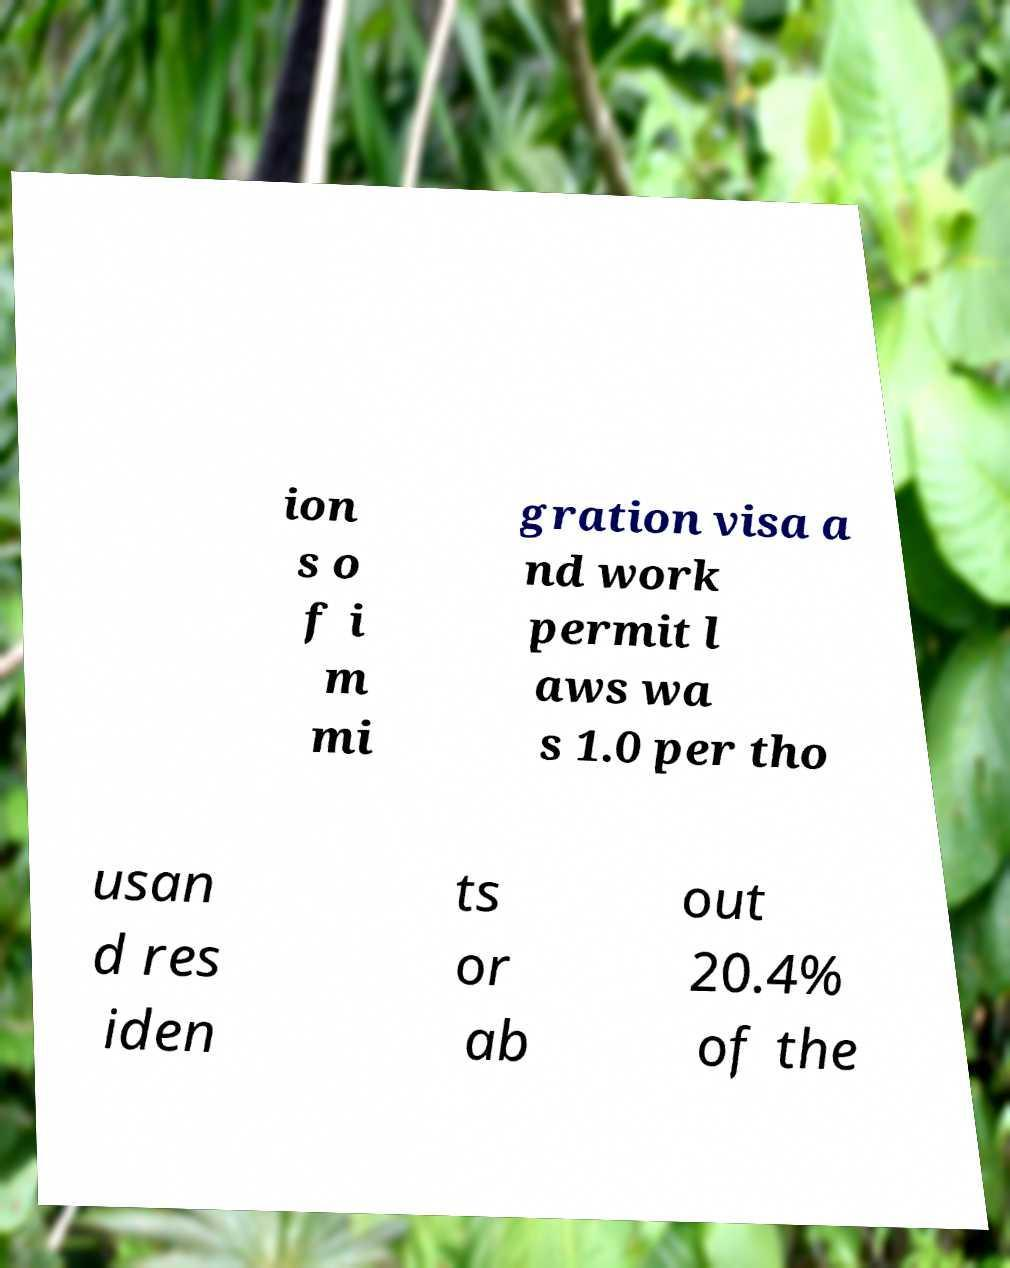I need the written content from this picture converted into text. Can you do that? ion s o f i m mi gration visa a nd work permit l aws wa s 1.0 per tho usan d res iden ts or ab out 20.4% of the 